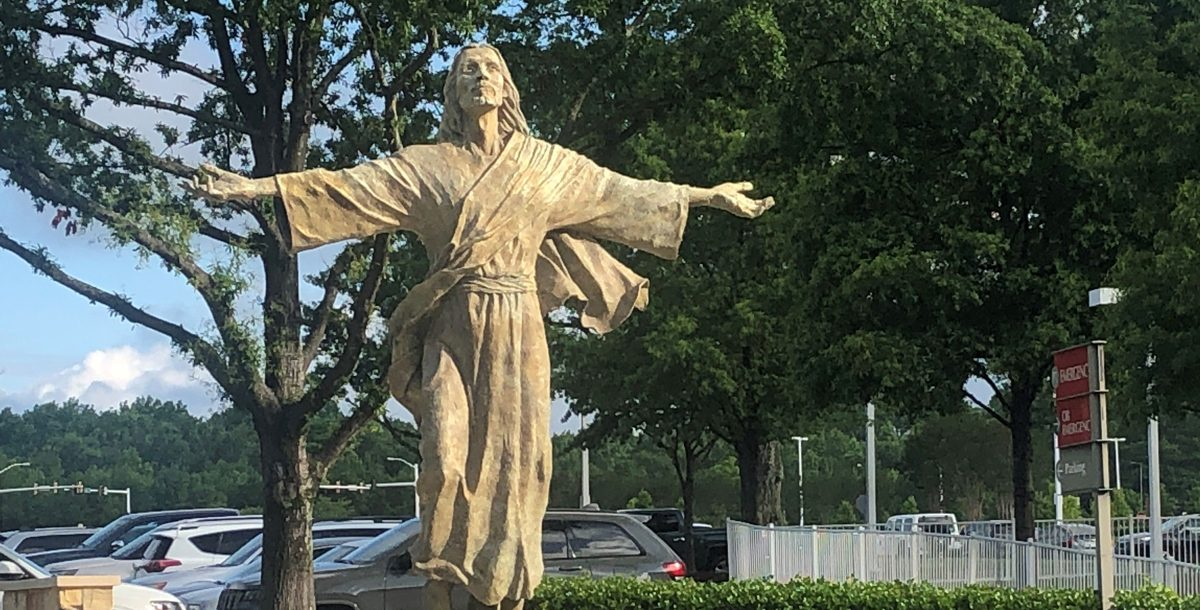What elements of the statue suggest it might be significant to local history or culture? The traditional robe and welcoming gesture of the statue might symbolize a locally revered figure, possibly connected to regional religious or cultural narratives. Its material and style of sculpture might also reflect local artistic traditions, resonating with communal identity and pride. 